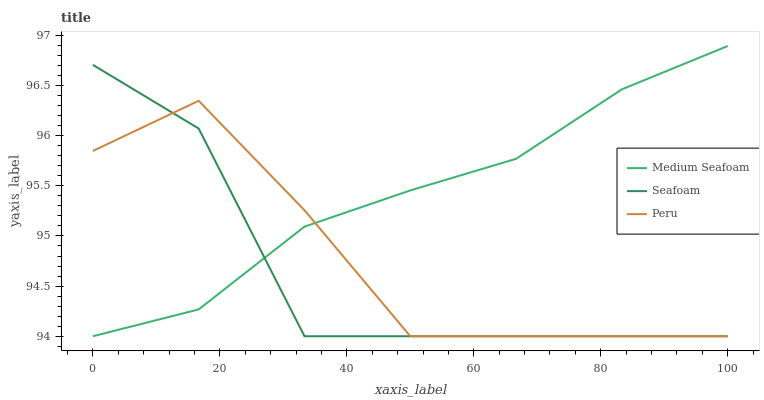Does Seafoam have the minimum area under the curve?
Answer yes or no. Yes. Does Medium Seafoam have the maximum area under the curve?
Answer yes or no. Yes. Does Peru have the minimum area under the curve?
Answer yes or no. No. Does Peru have the maximum area under the curve?
Answer yes or no. No. Is Medium Seafoam the smoothest?
Answer yes or no. Yes. Is Seafoam the roughest?
Answer yes or no. Yes. Is Peru the smoothest?
Answer yes or no. No. Is Peru the roughest?
Answer yes or no. No. Does Medium Seafoam have the lowest value?
Answer yes or no. Yes. Does Medium Seafoam have the highest value?
Answer yes or no. Yes. Does Seafoam have the highest value?
Answer yes or no. No. Does Seafoam intersect Medium Seafoam?
Answer yes or no. Yes. Is Seafoam less than Medium Seafoam?
Answer yes or no. No. Is Seafoam greater than Medium Seafoam?
Answer yes or no. No. 